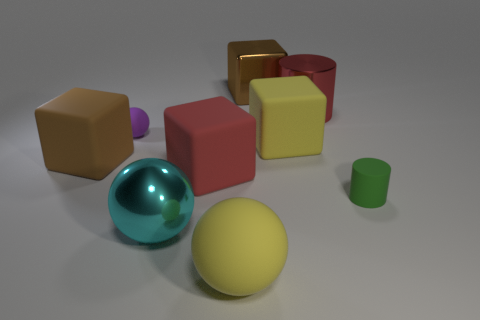Subtract all matte balls. How many balls are left? 1 Subtract all brown cubes. How many cubes are left? 2 Subtract 2 cylinders. How many cylinders are left? 0 Subtract all gray blocks. Subtract all red cylinders. How many blocks are left? 4 Subtract all purple spheres. How many gray blocks are left? 0 Subtract all large yellow matte spheres. Subtract all tiny purple rubber things. How many objects are left? 7 Add 3 rubber things. How many rubber things are left? 9 Add 2 big rubber objects. How many big rubber objects exist? 6 Subtract 0 brown cylinders. How many objects are left? 9 Subtract all spheres. How many objects are left? 6 